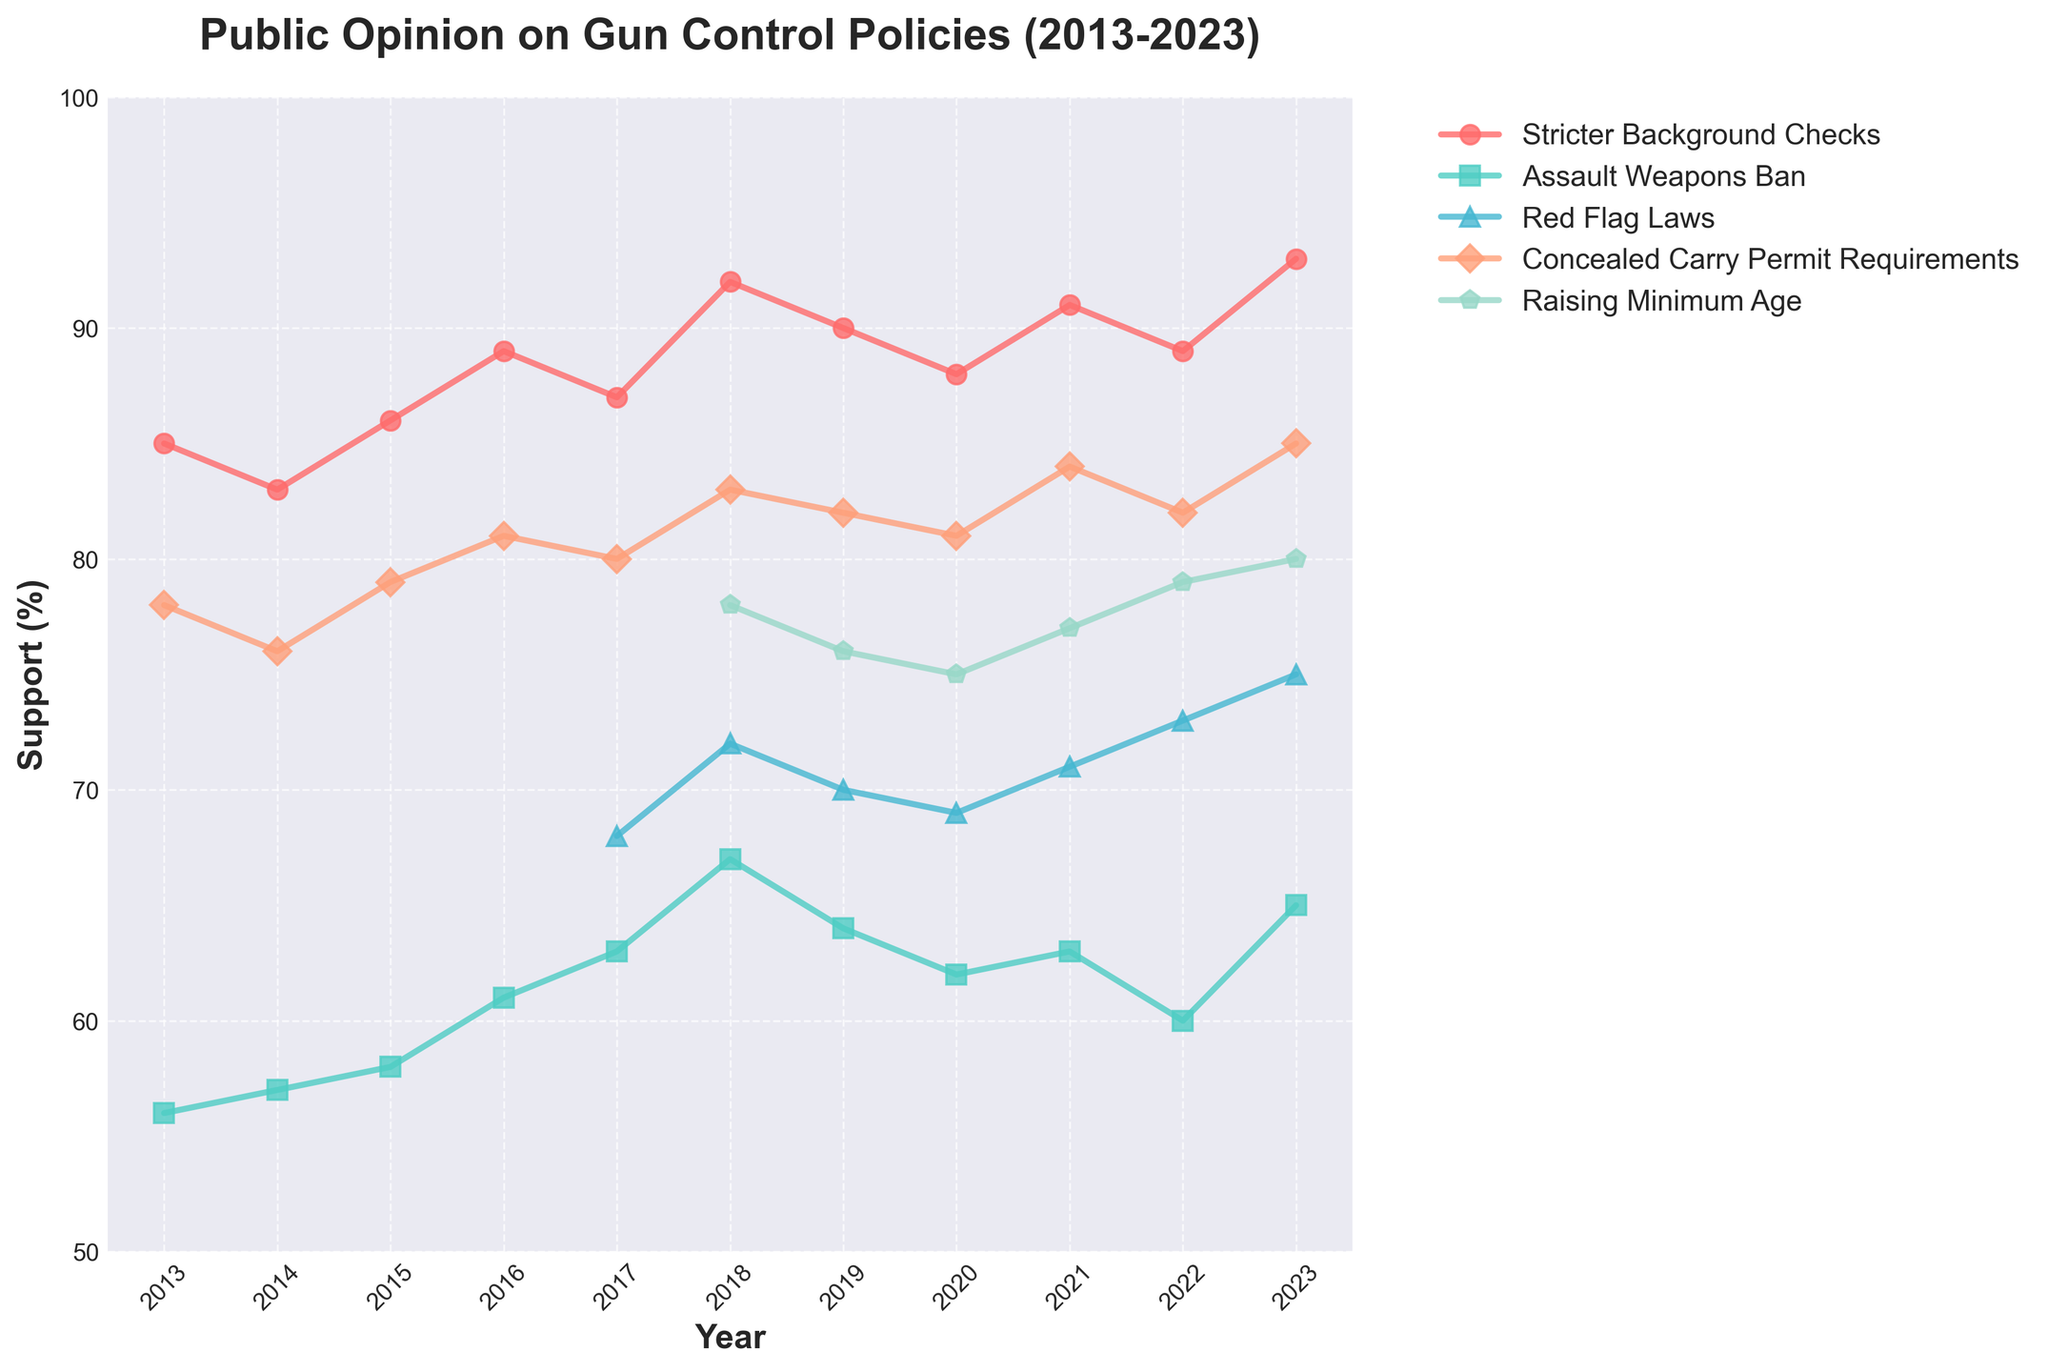Which policy option has the most consistent support over the past decade? By observing the lines, the policy with the least fluctuation in its percentage over the years is "Stricter Background Checks", which consistently stays near 85%-93%.
Answer: Stricter Background Checks What was the average support for the Assault Weapons Ban between 2015 and 2020? First, identify the values: 2015 (58), 2016 (61), 2017 (63), 2018 (67), 2019 (64), 2020 (62). Sum these values: 58 + 61 + 63 + 67 + 64 + 62 = 375. Then divide by the number of years, which is 6: 375 / 6 = 62.5.
Answer: 62.5 What year showed the highest support for Red Flag Laws? By visually inspecting the line for "Red Flag Laws", the highest point is in the year 2023.
Answer: 2023 Which year did the "Raising Minimum Age" policy option see its lowest support? Observing the line for "Raising Minimum Age", the lowest point is in the year 2019 with a percentage of 76.
Answer: 2019 How many policy options had support higher than 80% in 2018? Checking each policy line in 2018:
- Stricter Background Checks: 92%
- Assault Weapons Ban: 67%
- Red Flag Laws: 72%
- Concealed Carry Permit Requirements: 83%
- Raising Minimum Age: 78%
Only "Stricter Background Checks" and "Concealed Carry Permit Requirements” are above 80%.
Answer: 2 Did the support for Assault Weapons Ban ever surpass 65%? If yes, in which years? Checking the "Assault Weapons Ban" line, it surpasses 65% in 2018 (67%) and 2023 (65%).
Answer: 2018, 2023 Which visual indicator shows the representation for "Concealed Carry Permit Requirements"? The visual indicator for "Concealed Carry Permit Requirements" is the plot line marked with squares.
Answer: Squares What was the percent difference in support for "Stricter Background Checks" between 2015 and 2023? Support in 2015 was 86%, and in 2023 it was 93%. The difference is 93 - 86 = 7%.
Answer: 7% Is there a year where support for all policy options (available data) simultaneously increased compared to the previous year? Comparing year-over-year changes:
- From 2017 to 2018, all visible options saw increased support:
   - Stricter Background Checks (87% to 92%)
   - Assault Weapons Ban (63% to 67%)
   - Concealed Carry Permit Requirements (80% to 83%)
   - Raising Minimum Age (N/A to 78%, first data available)
   - Red Flag Laws (68% to 72%)
This makes 2018 the year where all available options saw simultaneous increase.
Answer: 2018 